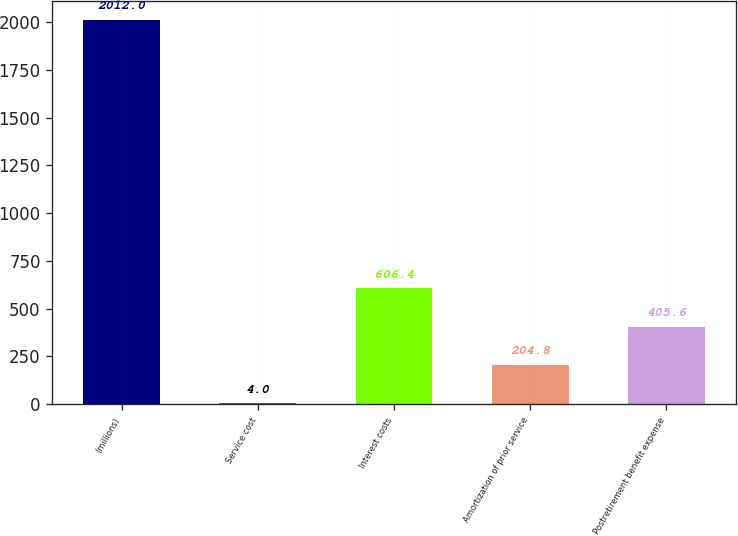Convert chart. <chart><loc_0><loc_0><loc_500><loc_500><bar_chart><fcel>(millions)<fcel>Service cost<fcel>Interest costs<fcel>Amortization of prior service<fcel>Postretirement benefit expense<nl><fcel>2012<fcel>4<fcel>606.4<fcel>204.8<fcel>405.6<nl></chart> 